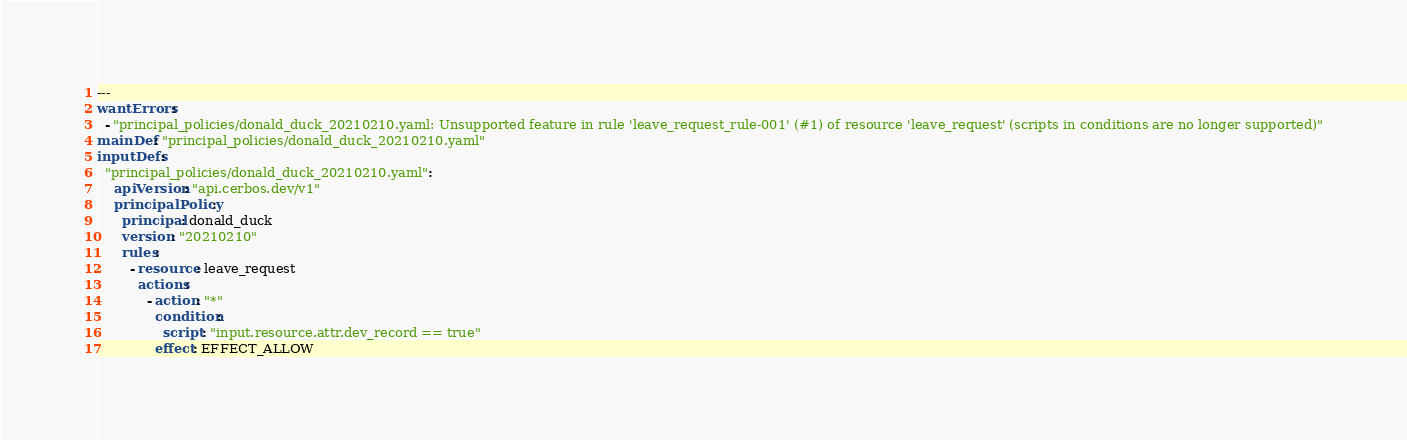Convert code to text. <code><loc_0><loc_0><loc_500><loc_500><_YAML_>---
wantErrors:
  - "principal_policies/donald_duck_20210210.yaml: Unsupported feature in rule 'leave_request_rule-001' (#1) of resource 'leave_request' (scripts in conditions are no longer supported)"
mainDef: "principal_policies/donald_duck_20210210.yaml"
inputDefs:
  "principal_policies/donald_duck_20210210.yaml":
    apiVersion: "api.cerbos.dev/v1"
    principalPolicy:
      principal: donald_duck
      version: "20210210"
      rules:
        - resource: leave_request
          actions:
            - action: "*"
              condition:
                script: "input.resource.attr.dev_record == true"
              effect: EFFECT_ALLOW
</code> 